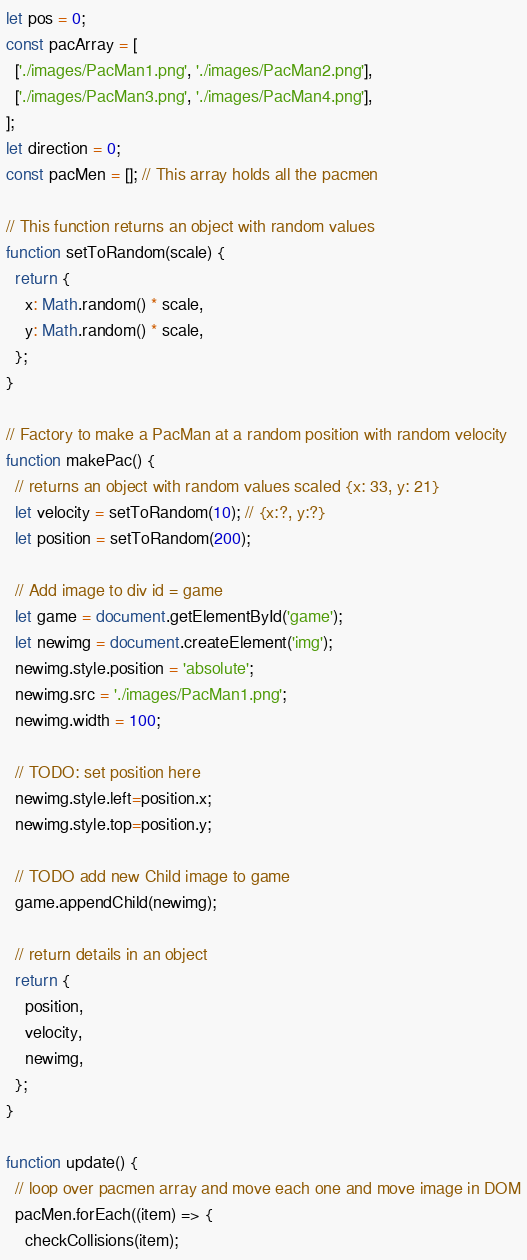<code> <loc_0><loc_0><loc_500><loc_500><_JavaScript_>let pos = 0;
const pacArray = [
  ['./images/PacMan1.png', './images/PacMan2.png'],
  ['./images/PacMan3.png', './images/PacMan4.png'],
];
let direction = 0;
const pacMen = []; // This array holds all the pacmen

// This function returns an object with random values
function setToRandom(scale) {
  return {
    x: Math.random() * scale,
    y: Math.random() * scale,
  };
}

// Factory to make a PacMan at a random position with random velocity
function makePac() {
  // returns an object with random values scaled {x: 33, y: 21}
  let velocity = setToRandom(10); // {x:?, y:?}
  let position = setToRandom(200);

  // Add image to div id = game
  let game = document.getElementById('game');
  let newimg = document.createElement('img');
  newimg.style.position = 'absolute';
  newimg.src = './images/PacMan1.png';
  newimg.width = 100;

  // TODO: set position here
  newimg.style.left=position.x;
  newimg.style.top=position.y;

  // TODO add new Child image to game
  game.appendChild(newimg);

  // return details in an object
  return {
    position,
    velocity,
    newimg,
  };
}

function update() {
  // loop over pacmen array and move each one and move image in DOM
  pacMen.forEach((item) => {
    checkCollisions(item);</code> 